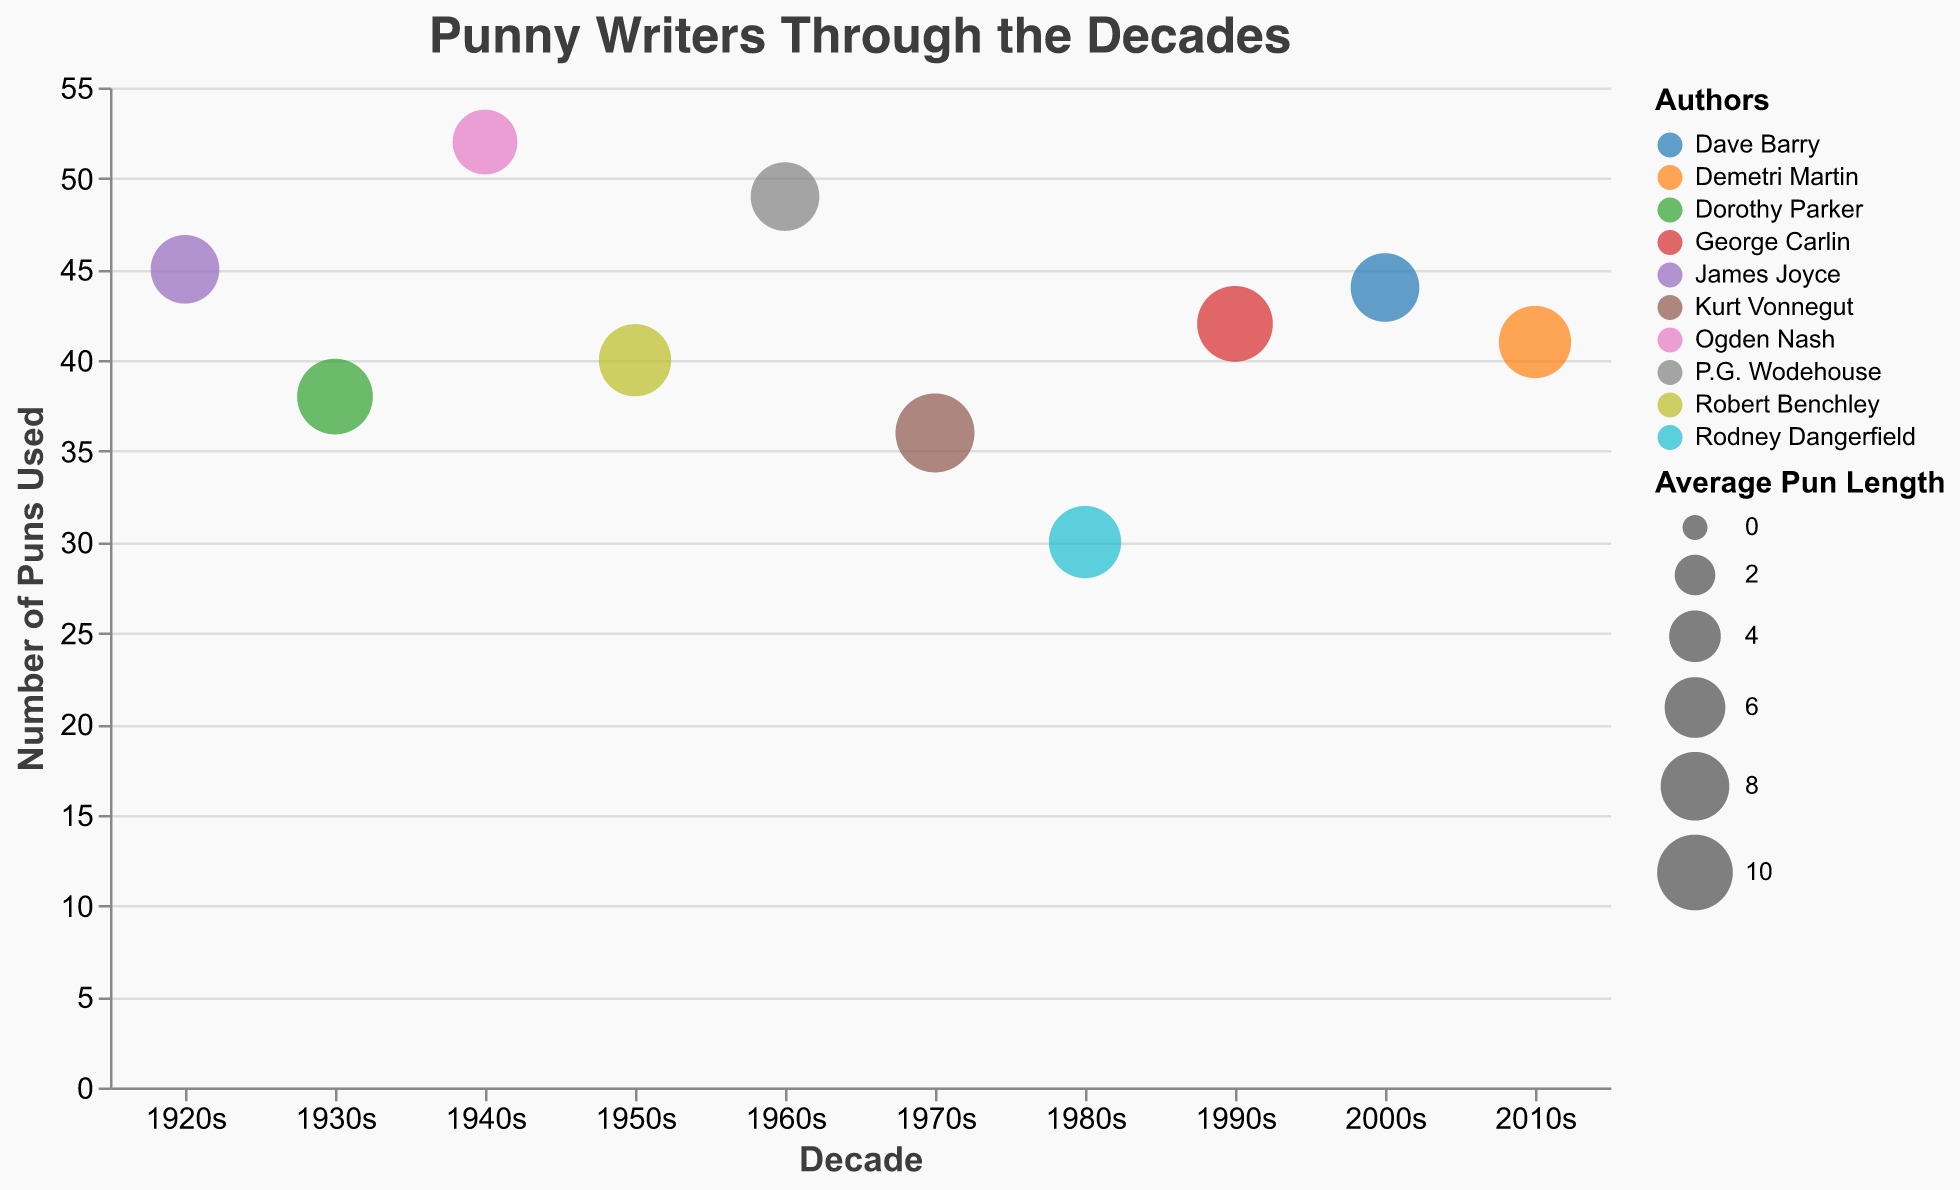Which decade has the highest number of puns used? To determine this, look at the y-axis (Number of Puns Used) and find the tallest bubble. This bubble is in the 1940s.
Answer: 1940s Which author used puns with the longest average length? To answer this, check the size of the bubbles as the size indicates the average length. The biggest bubble belongs to Kurt Vonnegut in the 1970s.
Answer: Kurt Vonnegut What is the title of the chart? Look at the top of the chart where the title text is displayed.
Answer: Punny Writers Through the Decades How many puns did Demetri Martin use in the 2010s? Locate the decade 2010s on the x-axis and find the bubble for Demetri Martin. Refer to the y-axis value of that bubble.
Answer: 41 What is the average number of puns used in each decade? Sum the total number of puns used in all decades, then divide by the number of decades (10). This calculation follows: (45+38+52+40+49+36+30+42+44+41) / 10 = 41.7
Answer: 41.7 Which two decades have the closest average length of puns? By comparing the bubble sizes visually, James Joyce in the 1920s and P.G. Wodehouse in the 1960s both have very similar average lengths.
Answer: 1920s and 1960s Which decade featured the author with the smallest number of puns used? Find the smallest bubble along the y-axis. Rodney Dangerfield in the 1980s used the least number of puns.
Answer: 1980s Compare George Carlin's and Dorothy Parker's numbers of puns used. Look at the bubbles for George Carlin (1990s) and Dorothy Parker (1930s). George Carlin used 42, while Dorothy Parker used 38 puns.
Answer: George Carlin used more puns Does the transparency of the bubbles aid in distinguishing overlaps in the data? Transparency helps to view overlapping data points more clearly, preventing them from obscuring one another. With translucent bubbles, we can differentiate overlapping bubbles more effectively.
Answer: Yes How did the use of puns change from the 1930s to the 1940s? Check the y-axis values for these two decades. Puns used increased from 38 in the 1930s to 52 in the 1940s.
Answer: Increased 